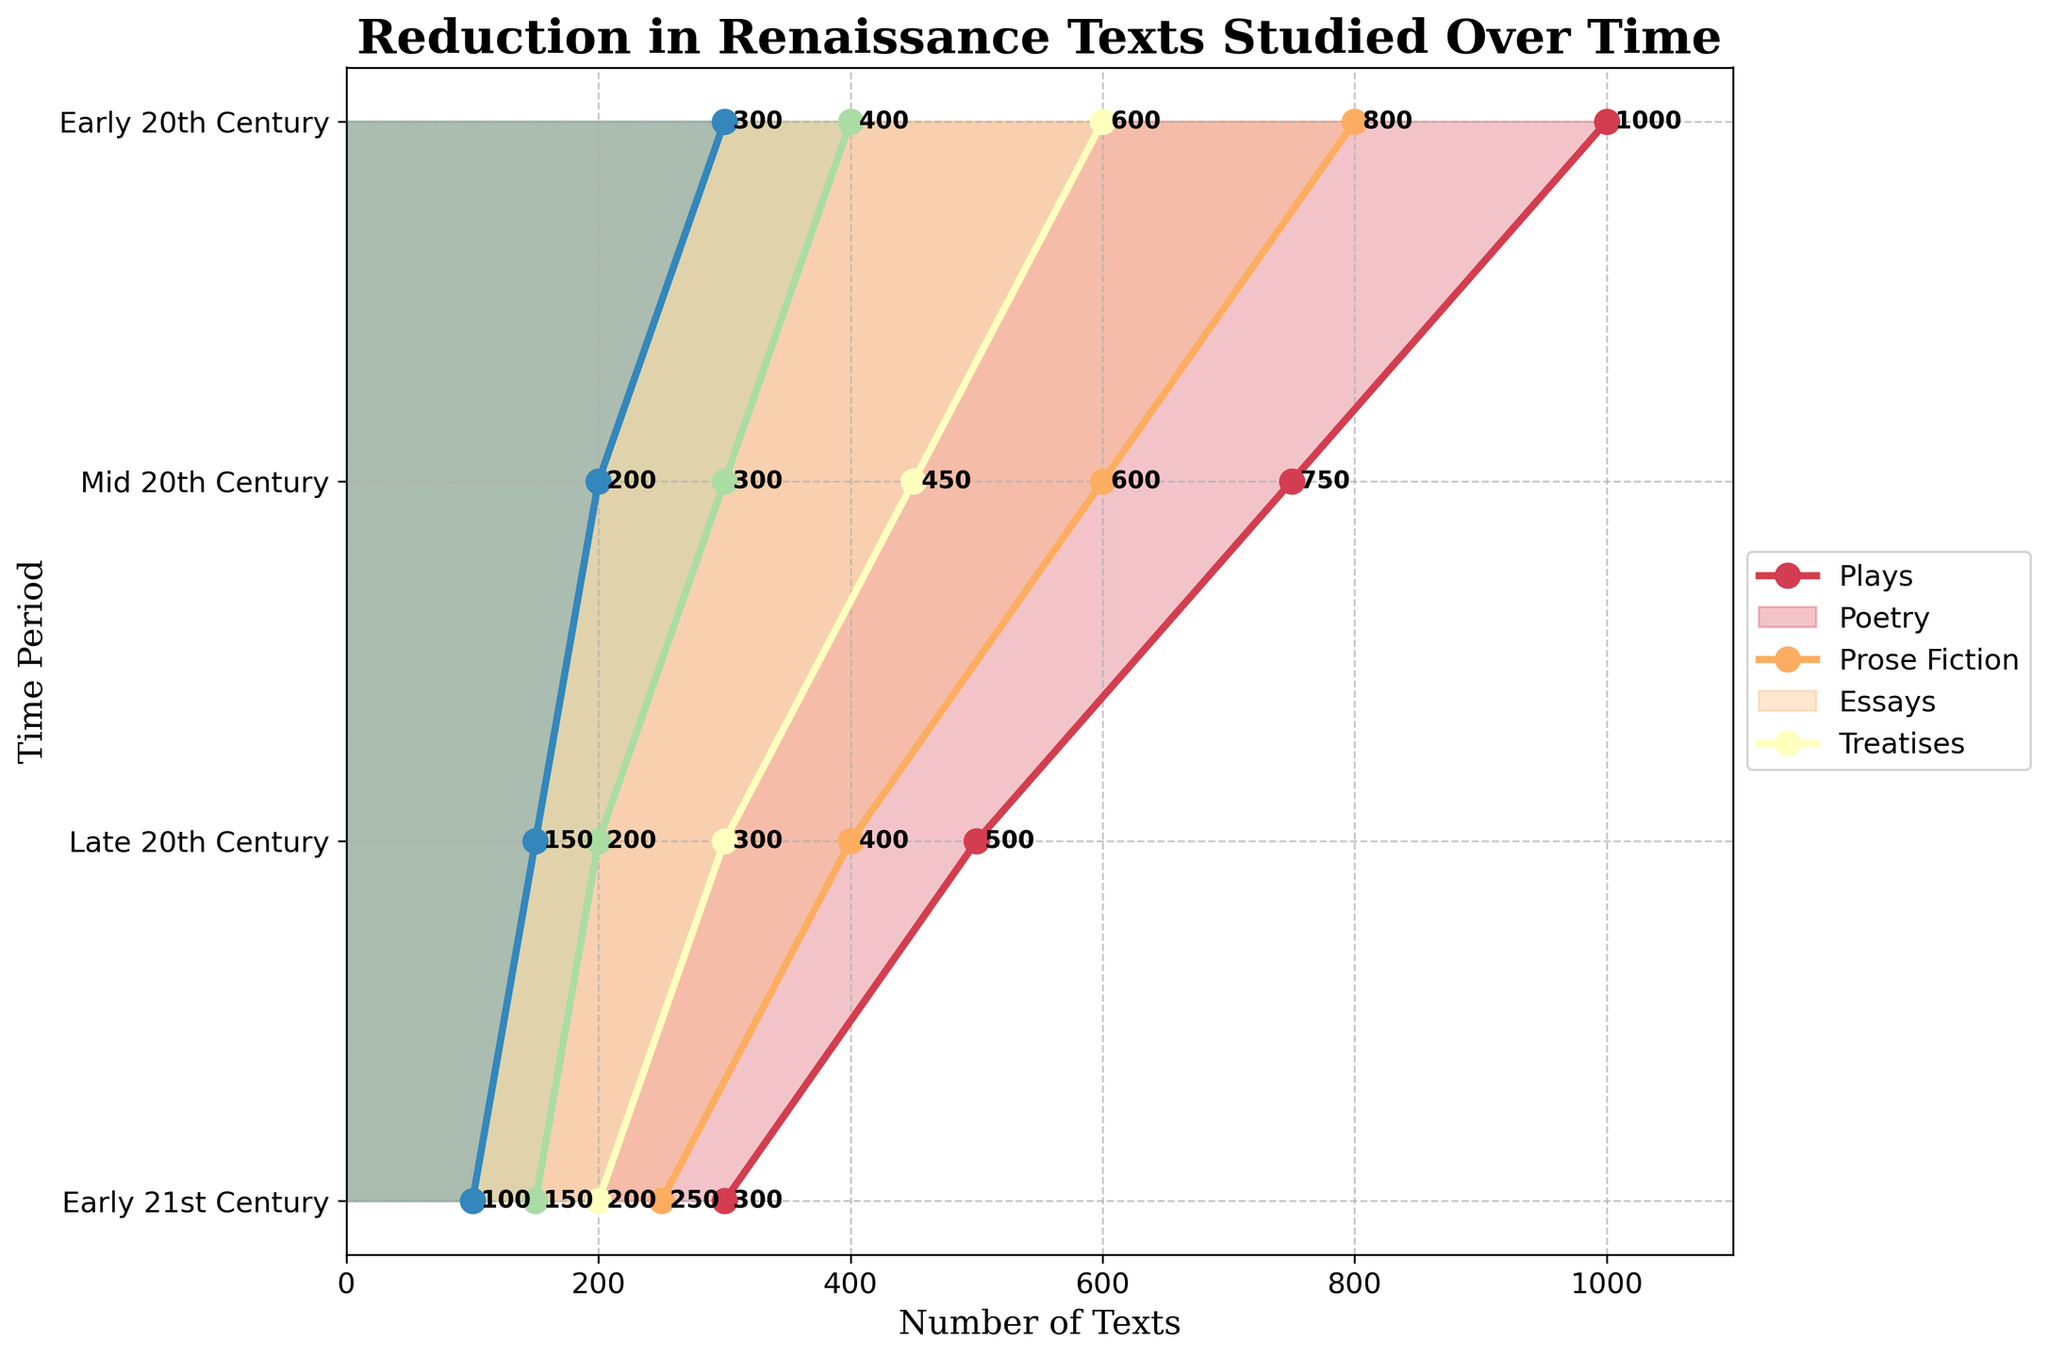what is the title of the plot? The title is located at the top and reads "Reduction in Renaissance Texts Studied Over Time"
Answer: Reduction in Renaissance Texts Studied Over Time what is the x-axis label? The x-axis is labeled "Number of Texts" indicating the values on this axis represent the count of texts.
Answer: Number of Texts which genre had the highest number of texts in the Early 20th Century? By comparing the values for each genre in the Early 20th Century, 'Plays' had the highest count at 1000 texts.
Answer: Plays how many time periods are represented in the plot? There are four time periods represented: Early 20th Century, Mid 20th Century, Late 20th Century, and Early 21st Century.
Answer: 4 what is the total number of texts for Essays across all time periods combined? Summing the number of texts for Essays across all periods: 400 + 300 + 200 + 150 = 1050.
Answer: 1050 which genre had the smallest reduction in the number of texts from the Early 20th Century to the Early 21st Century? Comparing the reduction for each genre: Plays (700), Poetry (550), Prose Fiction (400), Essays (250), and Treatises (200). Treatises had the smallest reduction.
Answer: Treatises was there a time period when 'Prose Fiction' and 'Essays' had the same number of texts? By examining each time period, in the Early 21st Century, both Prose Fiction and Essays had 150 texts.
Answer: Early 21st Century by how much did the number of 'Poetry' texts reduce from the Mid 20th Century to the Early 21st Century? Calculating the difference: 600 - 250 = 350. The number of Poetry texts reduced by 350 from Mid 20th to Early 21st Century.
Answer: 350 compare the decline in the number of 'Plays' and 'Poetry' texts from the Late 20th Century to the Early 21st Century. Which declined more and by how much? For Plays, the decline is 500 - 300 = 200. For Poetry, the decline is 400 - 250 = 150. Therefore, Plays declined more by 50 texts.
Answer: Plays, 50 how does the trend for 'Treatises' across the time periods compare to that for 'Poetry'? Both 'Treatises' and 'Poetry' exhibit a reduction in the number of texts over time, but 'Poetry' starts with higher values and declines more significantly than 'Treatises'.
Answer: Poetry declines more 